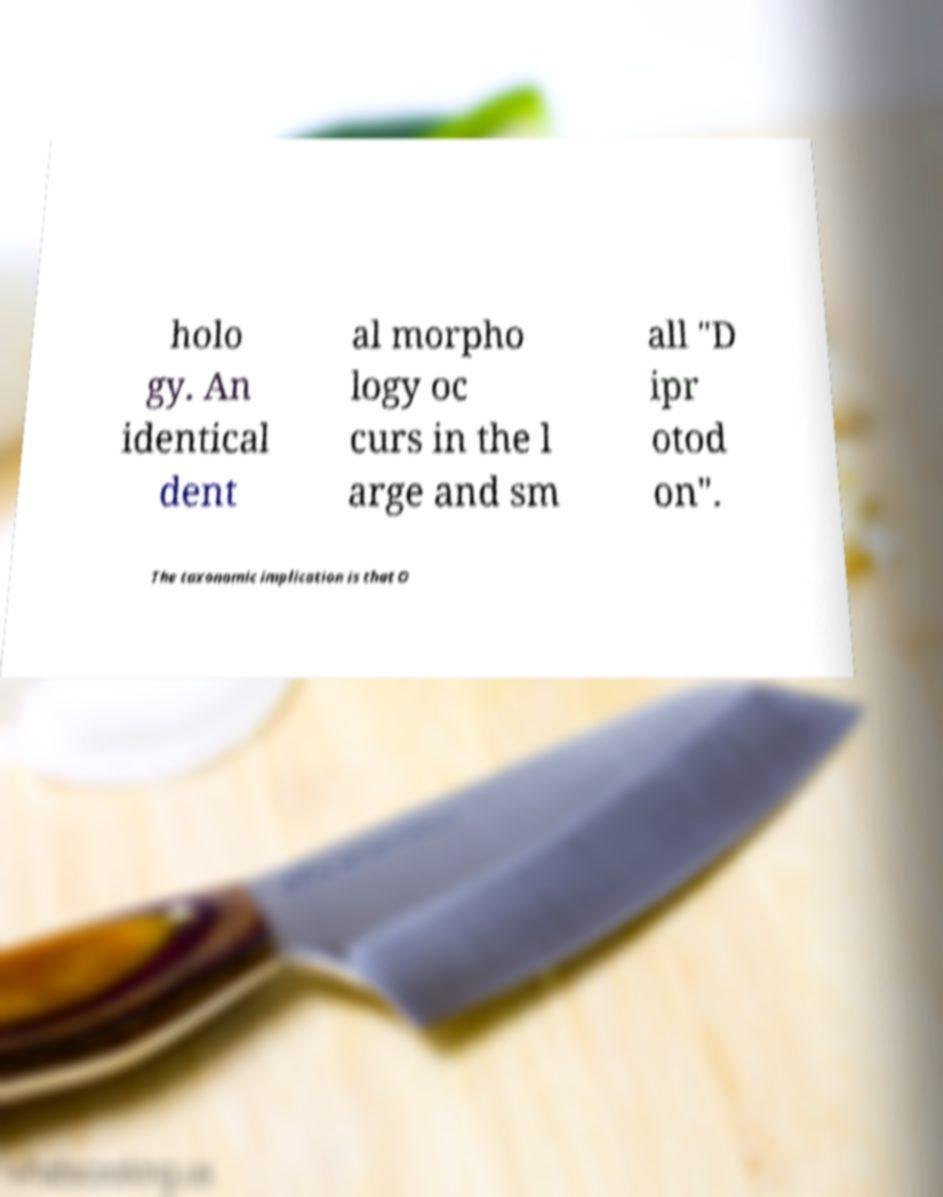For documentation purposes, I need the text within this image transcribed. Could you provide that? holo gy. An identical dent al morpho logy oc curs in the l arge and sm all "D ipr otod on". The taxonomic implication is that O 